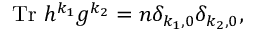Convert formula to latex. <formula><loc_0><loc_0><loc_500><loc_500>T r h ^ { k _ { 1 } } g ^ { k _ { 2 } } = n \delta _ { k _ { 1 } , 0 } \delta _ { k _ { 2 } , 0 } ,</formula> 